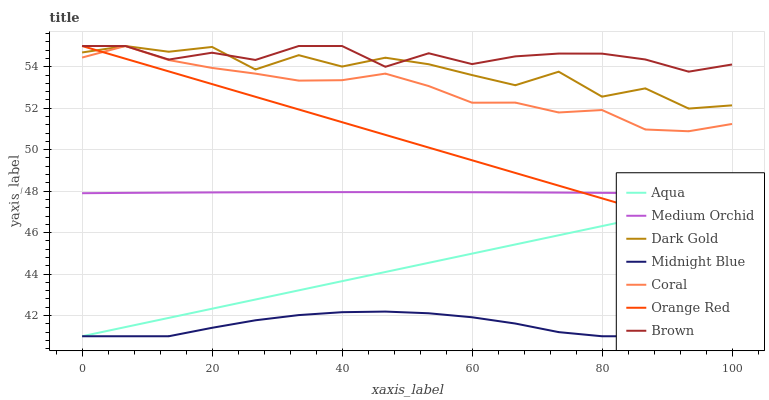Does Midnight Blue have the minimum area under the curve?
Answer yes or no. Yes. Does Brown have the maximum area under the curve?
Answer yes or no. Yes. Does Dark Gold have the minimum area under the curve?
Answer yes or no. No. Does Dark Gold have the maximum area under the curve?
Answer yes or no. No. Is Orange Red the smoothest?
Answer yes or no. Yes. Is Dark Gold the roughest?
Answer yes or no. Yes. Is Midnight Blue the smoothest?
Answer yes or no. No. Is Midnight Blue the roughest?
Answer yes or no. No. Does Midnight Blue have the lowest value?
Answer yes or no. Yes. Does Dark Gold have the lowest value?
Answer yes or no. No. Does Orange Red have the highest value?
Answer yes or no. Yes. Does Midnight Blue have the highest value?
Answer yes or no. No. Is Midnight Blue less than Brown?
Answer yes or no. Yes. Is Medium Orchid greater than Aqua?
Answer yes or no. Yes. Does Orange Red intersect Medium Orchid?
Answer yes or no. Yes. Is Orange Red less than Medium Orchid?
Answer yes or no. No. Is Orange Red greater than Medium Orchid?
Answer yes or no. No. Does Midnight Blue intersect Brown?
Answer yes or no. No. 